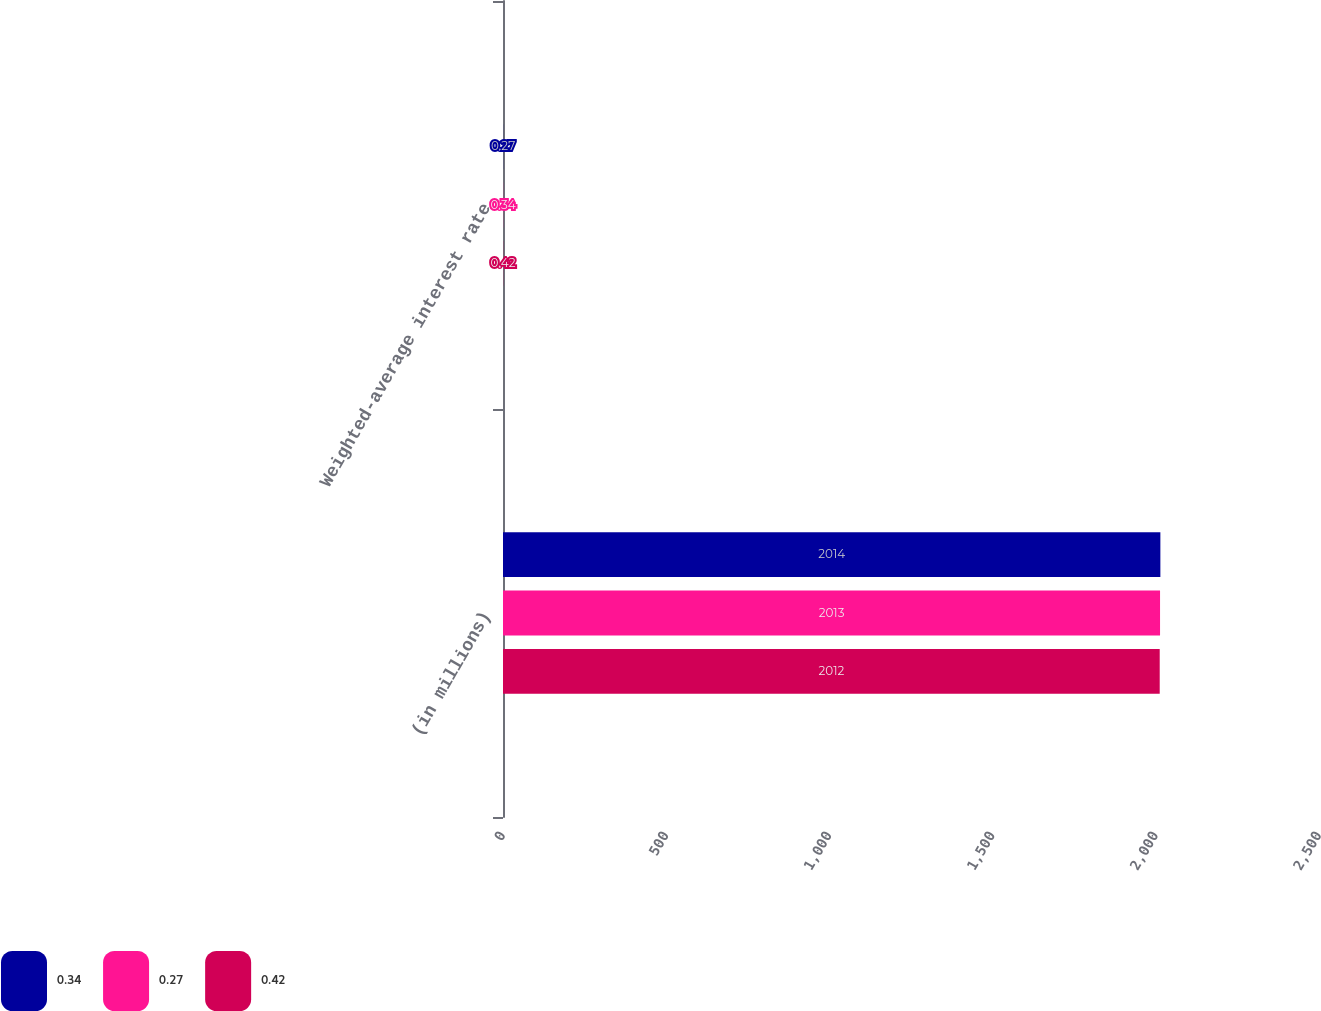Convert chart. <chart><loc_0><loc_0><loc_500><loc_500><stacked_bar_chart><ecel><fcel>(in millions)<fcel>Weighted-average interest rate<nl><fcel>0.34<fcel>2014<fcel>0.27<nl><fcel>0.27<fcel>2013<fcel>0.34<nl><fcel>0.42<fcel>2012<fcel>0.42<nl></chart> 